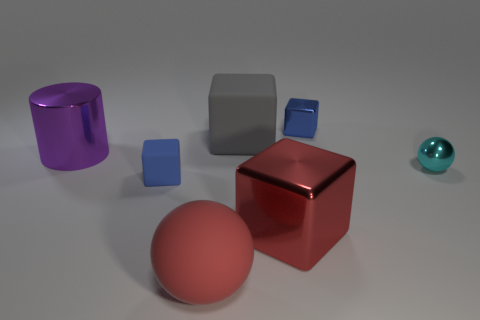There is a small object that is the same color as the tiny shiny block; what shape is it?
Keep it short and to the point. Cube. Is the number of blue matte things less than the number of gray metallic spheres?
Your answer should be very brief. No. Is there anything else of the same color as the large sphere?
Offer a terse response. Yes. There is a big purple object that is the same material as the cyan object; what shape is it?
Offer a very short reply. Cylinder. How many small cyan metallic things are in front of the large rubber thing in front of the sphere to the right of the big red sphere?
Provide a succinct answer. 0. The small thing that is left of the small cyan metallic ball and in front of the gray rubber object has what shape?
Provide a succinct answer. Cube. Is the number of large objects behind the gray object less than the number of small red shiny cylinders?
Ensure brevity in your answer.  No. How many tiny things are green cylinders or gray rubber cubes?
Provide a succinct answer. 0. How big is the cyan shiny thing?
Your answer should be compact. Small. There is a red matte object; what number of tiny metal cubes are on the left side of it?
Ensure brevity in your answer.  0. 